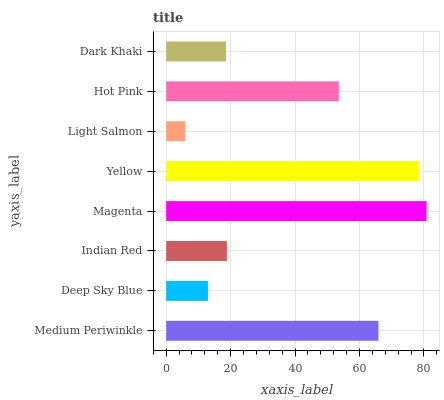Is Light Salmon the minimum?
Answer yes or no. Yes. Is Magenta the maximum?
Answer yes or no. Yes. Is Deep Sky Blue the minimum?
Answer yes or no. No. Is Deep Sky Blue the maximum?
Answer yes or no. No. Is Medium Periwinkle greater than Deep Sky Blue?
Answer yes or no. Yes. Is Deep Sky Blue less than Medium Periwinkle?
Answer yes or no. Yes. Is Deep Sky Blue greater than Medium Periwinkle?
Answer yes or no. No. Is Medium Periwinkle less than Deep Sky Blue?
Answer yes or no. No. Is Hot Pink the high median?
Answer yes or no. Yes. Is Indian Red the low median?
Answer yes or no. Yes. Is Indian Red the high median?
Answer yes or no. No. Is Medium Periwinkle the low median?
Answer yes or no. No. 